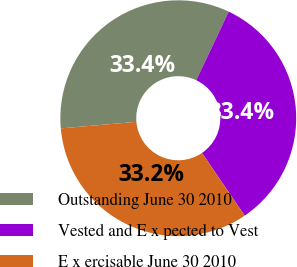Convert chart. <chart><loc_0><loc_0><loc_500><loc_500><pie_chart><fcel>Outstanding June 30 2010<fcel>Vested and E x pected to Vest<fcel>E x ercisable June 30 2010<nl><fcel>33.41%<fcel>33.44%<fcel>33.15%<nl></chart> 